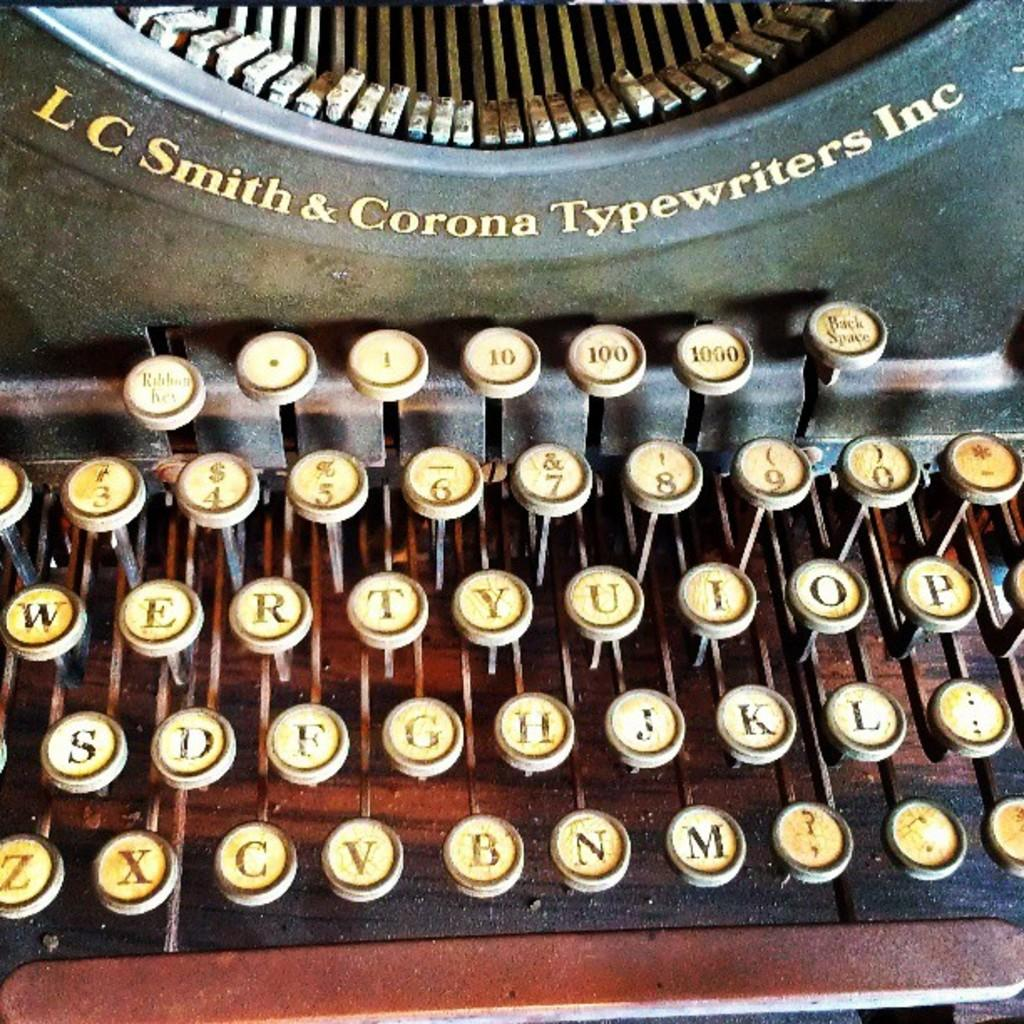<image>
Render a clear and concise summary of the photo. A LC Smith and Corona typewriter is displayed. 